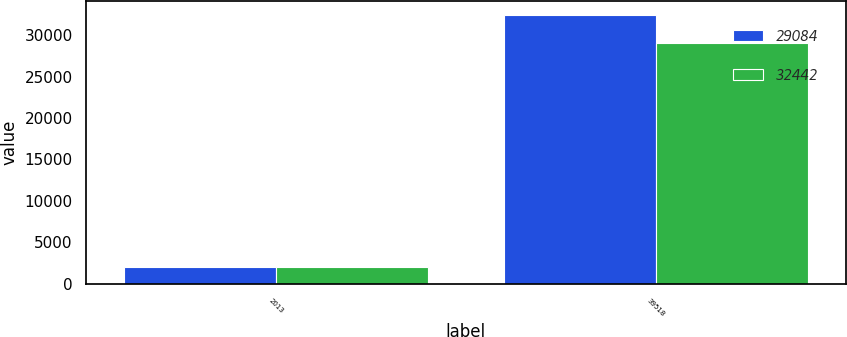<chart> <loc_0><loc_0><loc_500><loc_500><stacked_bar_chart><ecel><fcel>2013<fcel>39518<nl><fcel>29084<fcel>2012<fcel>32442<nl><fcel>32442<fcel>2011<fcel>29084<nl></chart> 